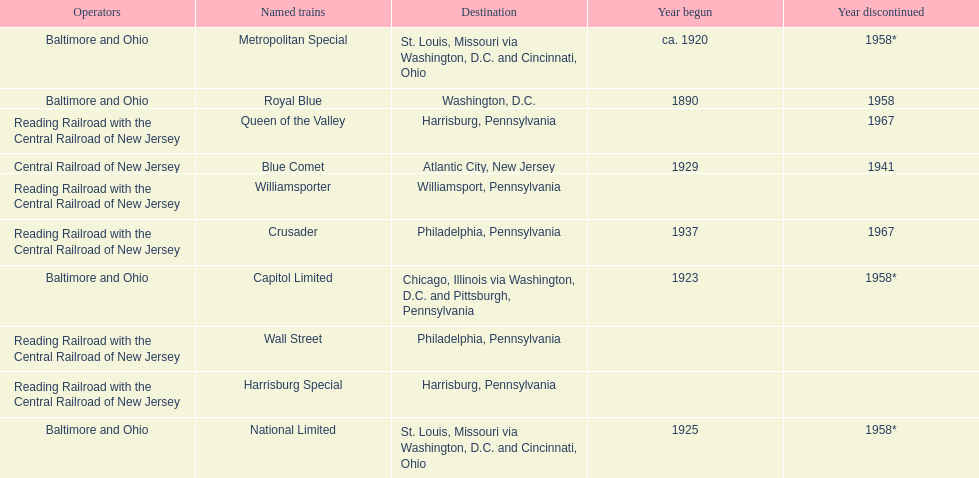How many trains were discontinued in 1958? 4. 